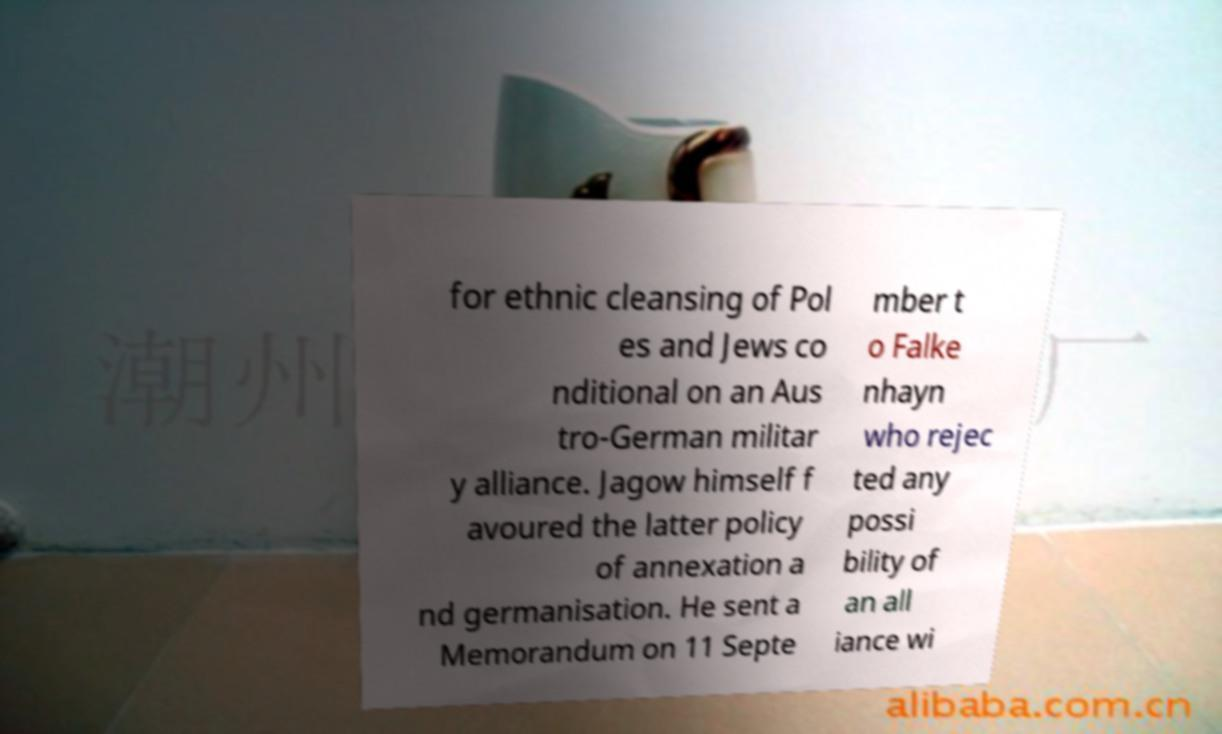Can you read and provide the text displayed in the image?This photo seems to have some interesting text. Can you extract and type it out for me? for ethnic cleansing of Pol es and Jews co nditional on an Aus tro-German militar y alliance. Jagow himself f avoured the latter policy of annexation a nd germanisation. He sent a Memorandum on 11 Septe mber t o Falke nhayn who rejec ted any possi bility of an all iance wi 